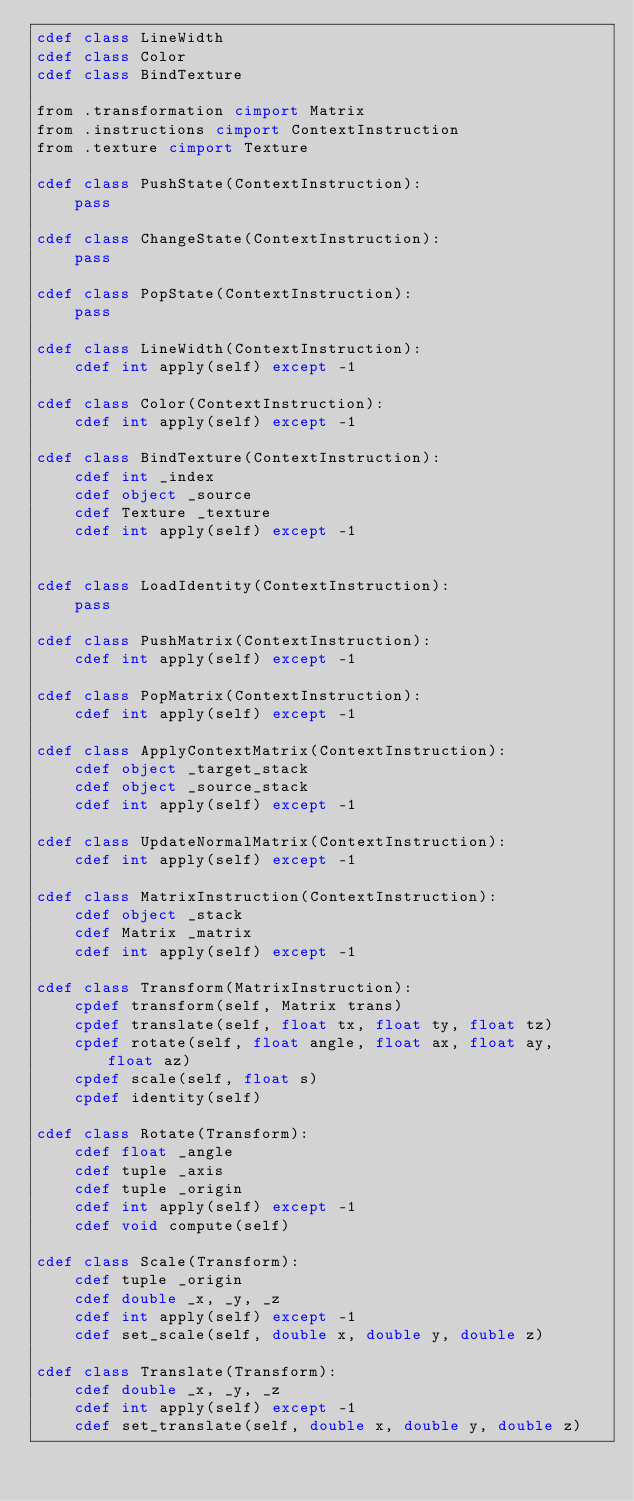Convert code to text. <code><loc_0><loc_0><loc_500><loc_500><_Cython_>cdef class LineWidth
cdef class Color
cdef class BindTexture

from .transformation cimport Matrix
from .instructions cimport ContextInstruction
from .texture cimport Texture

cdef class PushState(ContextInstruction):
    pass

cdef class ChangeState(ContextInstruction):
    pass

cdef class PopState(ContextInstruction):
    pass

cdef class LineWidth(ContextInstruction):
    cdef int apply(self) except -1

cdef class Color(ContextInstruction):
    cdef int apply(self) except -1

cdef class BindTexture(ContextInstruction):
    cdef int _index
    cdef object _source
    cdef Texture _texture
    cdef int apply(self) except -1


cdef class LoadIdentity(ContextInstruction):
    pass

cdef class PushMatrix(ContextInstruction):
    cdef int apply(self) except -1

cdef class PopMatrix(ContextInstruction):
    cdef int apply(self) except -1

cdef class ApplyContextMatrix(ContextInstruction):
    cdef object _target_stack
    cdef object _source_stack
    cdef int apply(self) except -1

cdef class UpdateNormalMatrix(ContextInstruction):
    cdef int apply(self) except -1

cdef class MatrixInstruction(ContextInstruction):
    cdef object _stack
    cdef Matrix _matrix
    cdef int apply(self) except -1

cdef class Transform(MatrixInstruction):
    cpdef transform(self, Matrix trans)
    cpdef translate(self, float tx, float ty, float tz)
    cpdef rotate(self, float angle, float ax, float ay, float az)
    cpdef scale(self, float s)
    cpdef identity(self)

cdef class Rotate(Transform):
    cdef float _angle
    cdef tuple _axis
    cdef tuple _origin
    cdef int apply(self) except -1
    cdef void compute(self)

cdef class Scale(Transform):
    cdef tuple _origin
    cdef double _x, _y, _z
    cdef int apply(self) except -1
    cdef set_scale(self, double x, double y, double z)

cdef class Translate(Transform):
    cdef double _x, _y, _z
    cdef int apply(self) except -1
    cdef set_translate(self, double x, double y, double z)

</code> 